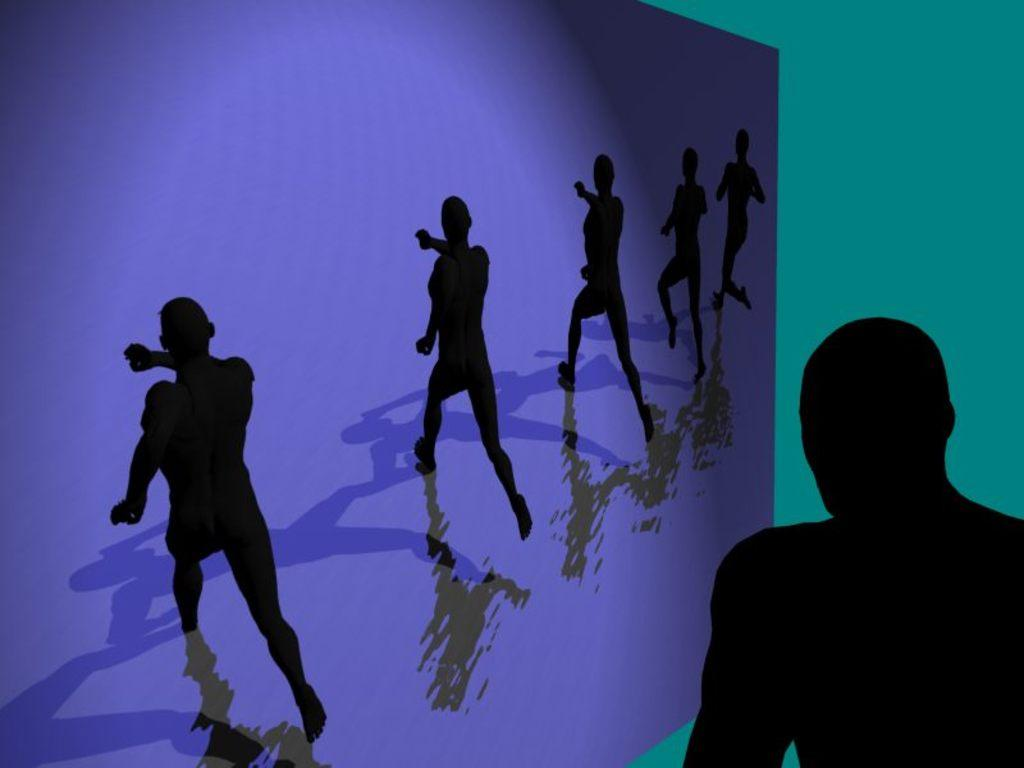How many people are present in the image? There are six persons in the image. What can be observed about the people in the image? There are shadows of the people in the image. What type of toothbrush is the zebra using in the image? There is no toothbrush or zebra present in the image. 